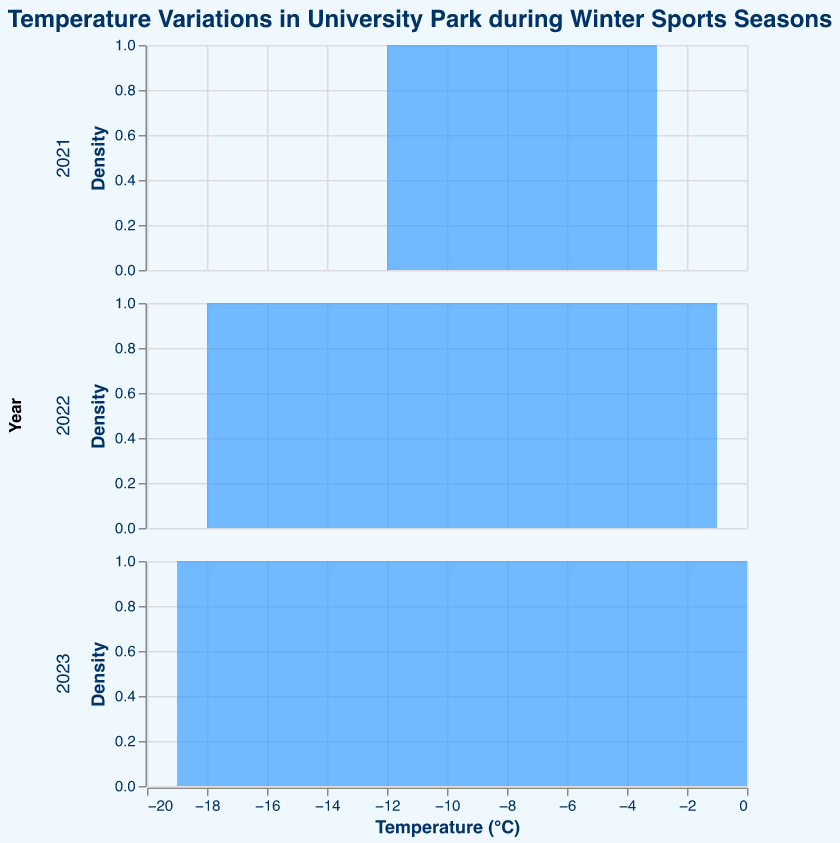What is the title of the plot? The title can be found at the top of the plot and reads: "Temperature Variations in University Park during Winter Sports Seasons."
Answer: Temperature Variations in University Park during Winter Sports Seasons How many years are represented in the plot? To determine the number of years, observe the row facets which are labeled with different years. In this case, there are rows labeled 2021, 2022, and 2023.
Answer: 3 What is the color used for the area in the density plot? The area in each subplot is filled with a specific color. The color used is a shade of blue.
Answer: Blue Which year shows the highest temperature variation in the subplot? The highest temperature variation indicates the range from the maximum to the minimum temperature within a year. In 2023, the temperature ranges from -19°C to 0°C, showing the highest variation.
Answer: 2023 What is the average of the minimum temperatures recorded in 2022 and 2023? The minimum temperatures are -18°C for 2022 and -19°C for 2023. The average is calculated as (-18 + -19) / 2 = -18.5°C.
Answer: -18.5°C In which month does the temperature reach its lowest point in the data set? By checking each subplot for the minimum point, the lowest temperature is -19°C and occurs in January 2023.
Answer: January 2023 How does the temperature in February 2022 compare to February 2023? In February 2022, the temperatures are -10°C and -8°C, while in February 2023, they are -11°C and -9°C. Both February 2022 temperatures are higher than those in February 2023.
Answer: February 2022 is warmer than February 2023 How many data points are there for each year? Observing the number of data points plotted within each year's subplot, each year (2021, 2022, and 2023) has 10 data points.
Answer: 10 What is the range of temperatures for 2021? In 2021, the highest temperature is -3°C and the lowest is -12°C. The range is calculated as -3 - (-12) = 9°C.
Answer: 9°C 